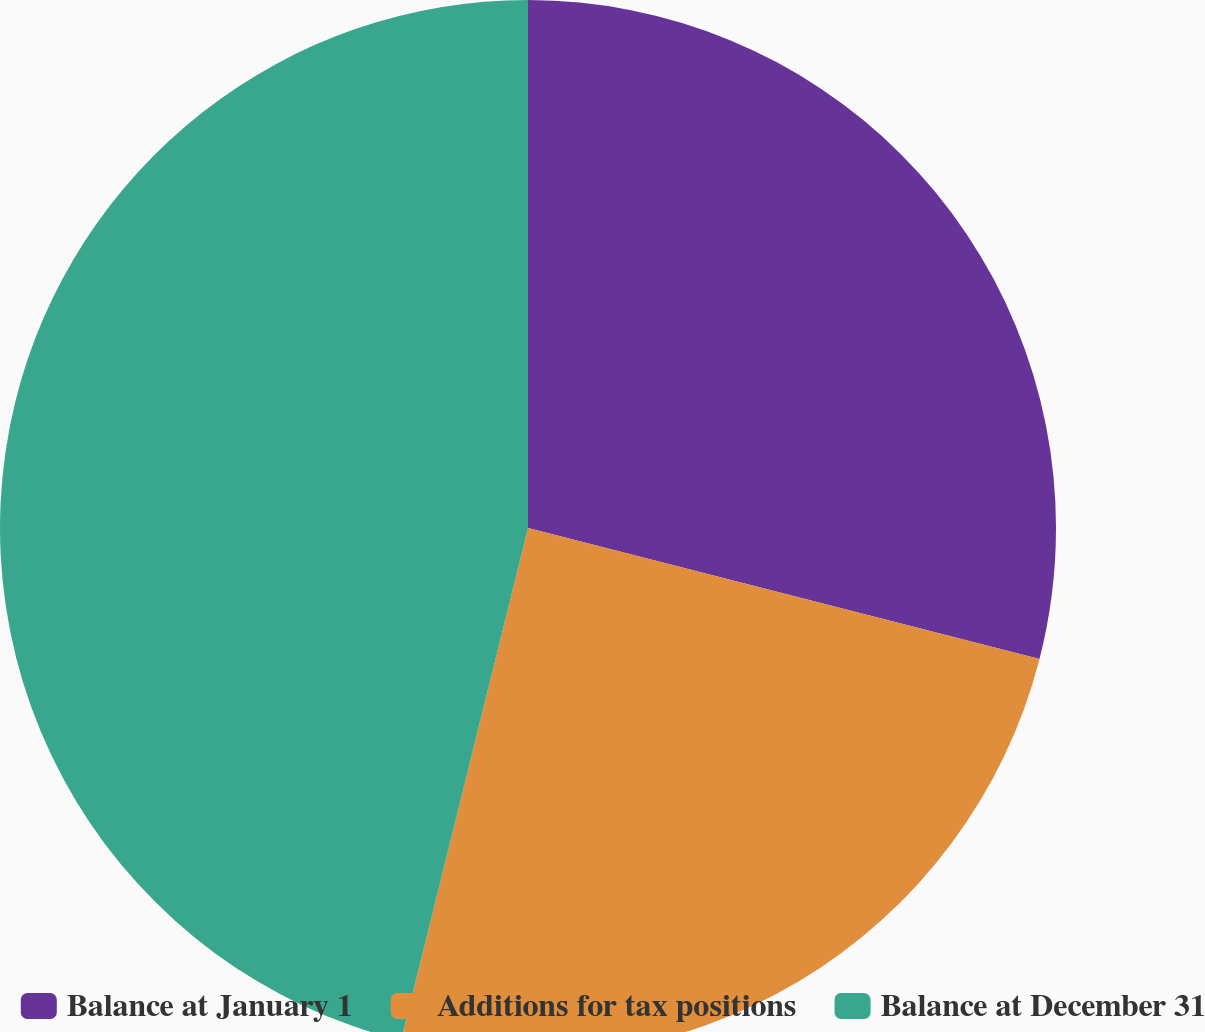Convert chart to OTSL. <chart><loc_0><loc_0><loc_500><loc_500><pie_chart><fcel>Balance at January 1<fcel>Additions for tax positions<fcel>Balance at December 31<nl><fcel>28.99%<fcel>24.88%<fcel>46.14%<nl></chart> 